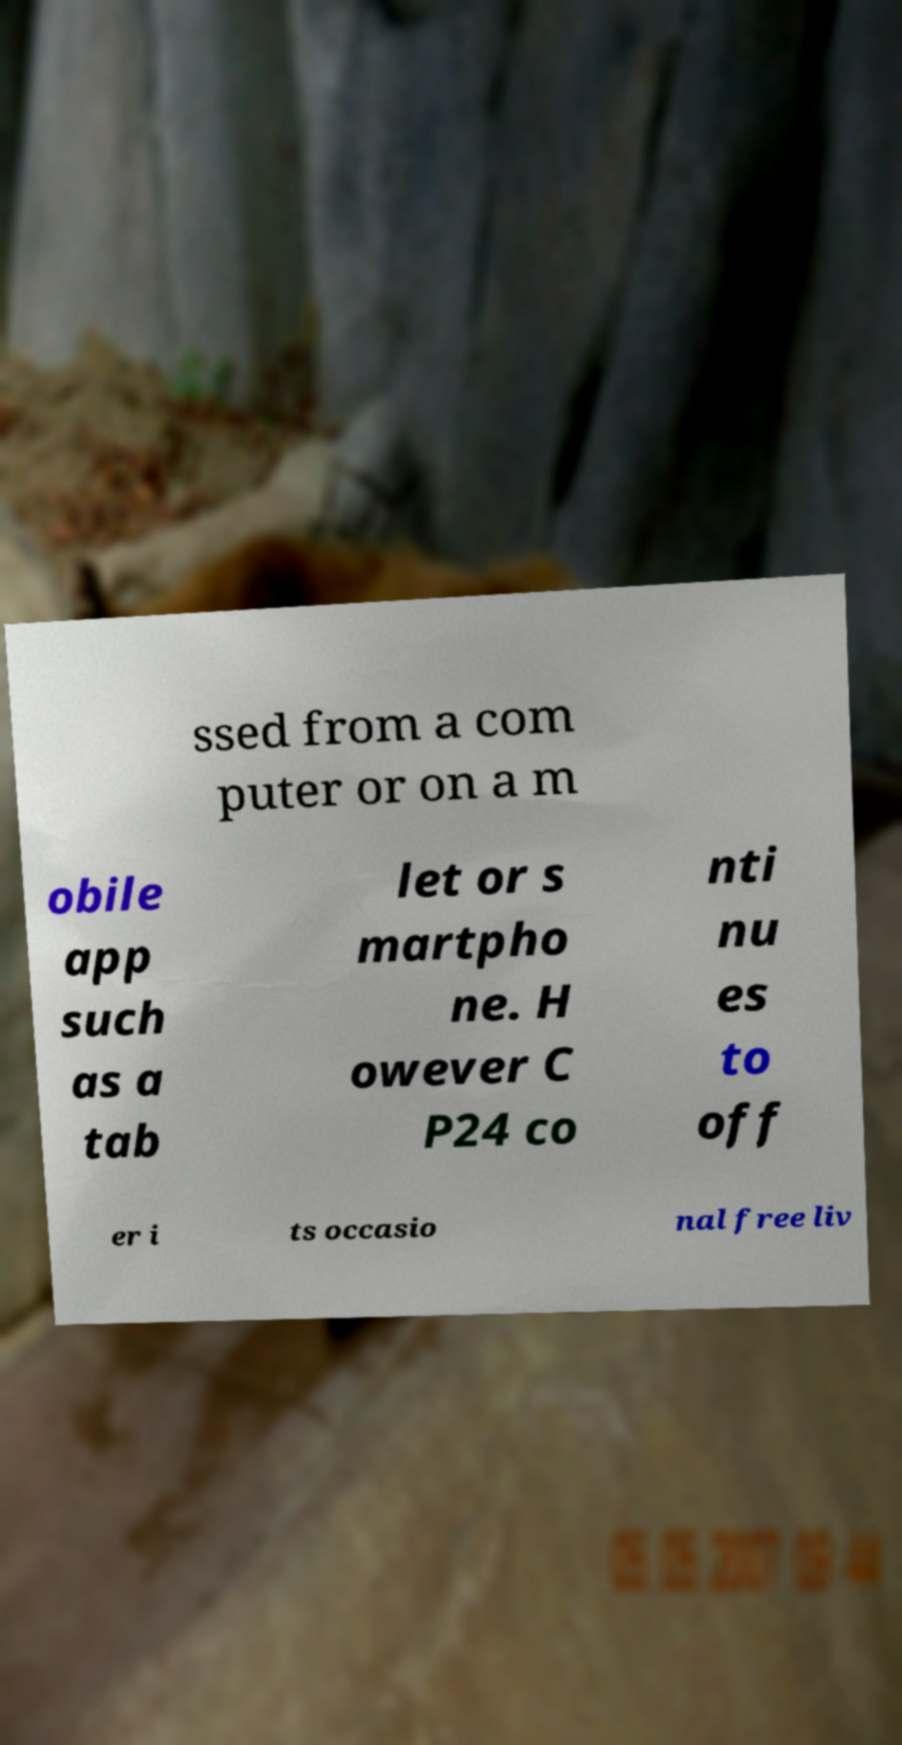Please read and relay the text visible in this image. What does it say? ssed from a com puter or on a m obile app such as a tab let or s martpho ne. H owever C P24 co nti nu es to off er i ts occasio nal free liv 